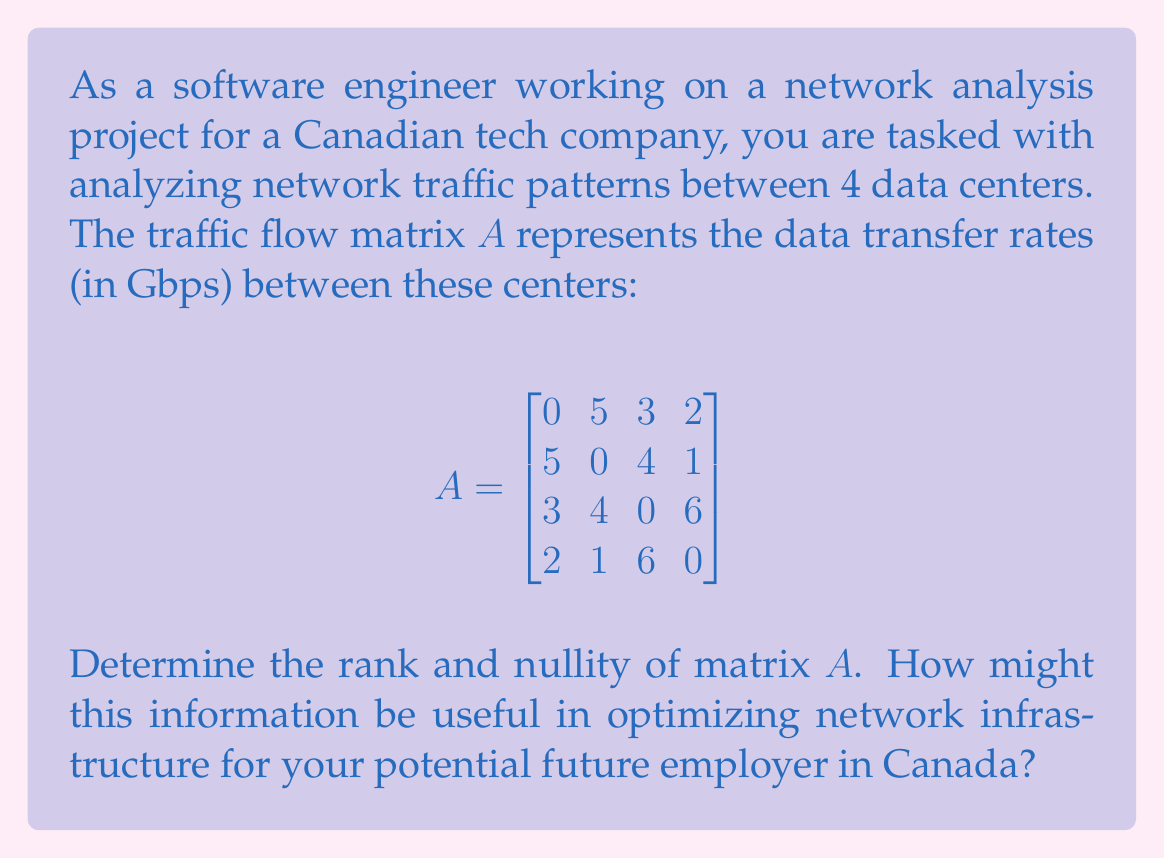Can you answer this question? To determine the rank and nullity of matrix $A$, we'll follow these steps:

1) First, we need to find the reduced row echelon form (RREF) of $A$. This will help us determine the rank.

$$\begin{bmatrix}
0 & 5 & 3 & 2 \\
5 & 0 & 4 & 1 \\
3 & 4 & 0 & 6 \\
2 & 1 & 6 & 0
\end{bmatrix} \sim
\begin{bmatrix}
1 & 0 & 0 & 0 \\
0 & 1 & 0 & 0 \\
0 & 0 & 1 & 0 \\
0 & 0 & 0 & 1
\end{bmatrix}$$

2) The rank of a matrix is equal to the number of non-zero rows in its RREF. Here, we see that all 4 rows are non-zero, so:

   $\text{rank}(A) = 4$

3) The nullity of a matrix is defined as:

   $\text{nullity}(A) = n - \text{rank}(A)$

   where $n$ is the number of columns in $A$.

4) In this case:

   $\text{nullity}(A) = 4 - 4 = 0$

5) Interpretation for network optimization:
   - The full rank (rank = 4) indicates that all data centers have unique traffic patterns.
   - This suggests that each data center plays a crucial role in the network topology.
   - The zero nullity implies there are no redundant connections or linear dependencies in the traffic patterns.
   - For optimization, this means that removing any data center would significantly impact the network structure.
   - In a Canadian context, where geographical distribution of data centers is important due to the country's vast size, this full rank suggests an efficient use of resources with no unnecessary duplication.
Answer: Rank of $A$ = 4
Nullity of $A$ = 0 